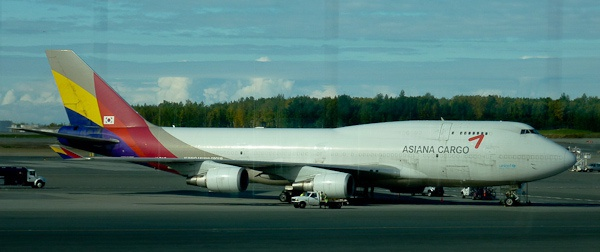Describe the objects in this image and their specific colors. I can see airplane in teal, darkgray, black, beige, and lightblue tones, truck in teal, black, and darkgreen tones, truck in teal, black, gray, and darkgray tones, truck in teal, darkgray, black, and lightgray tones, and truck in teal, black, and darkgreen tones in this image. 